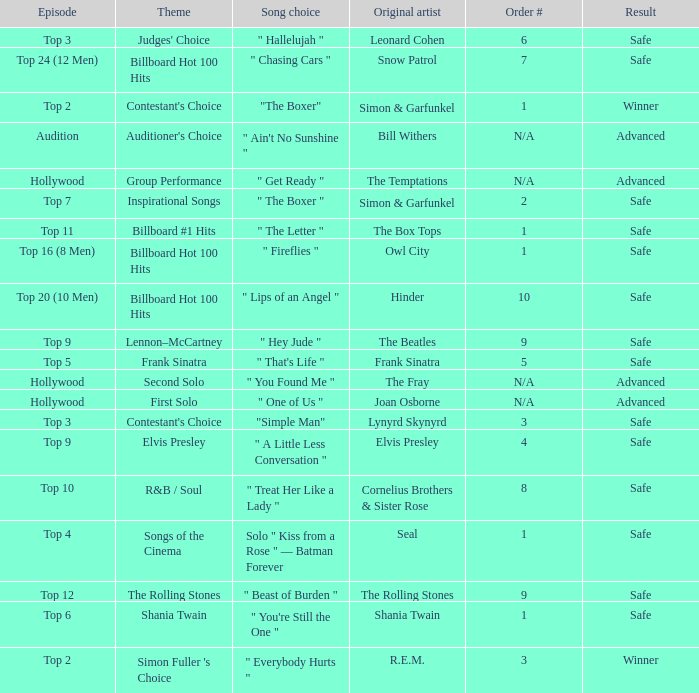In episode Top 16 (8 Men), what are the themes? Billboard Hot 100 Hits. 